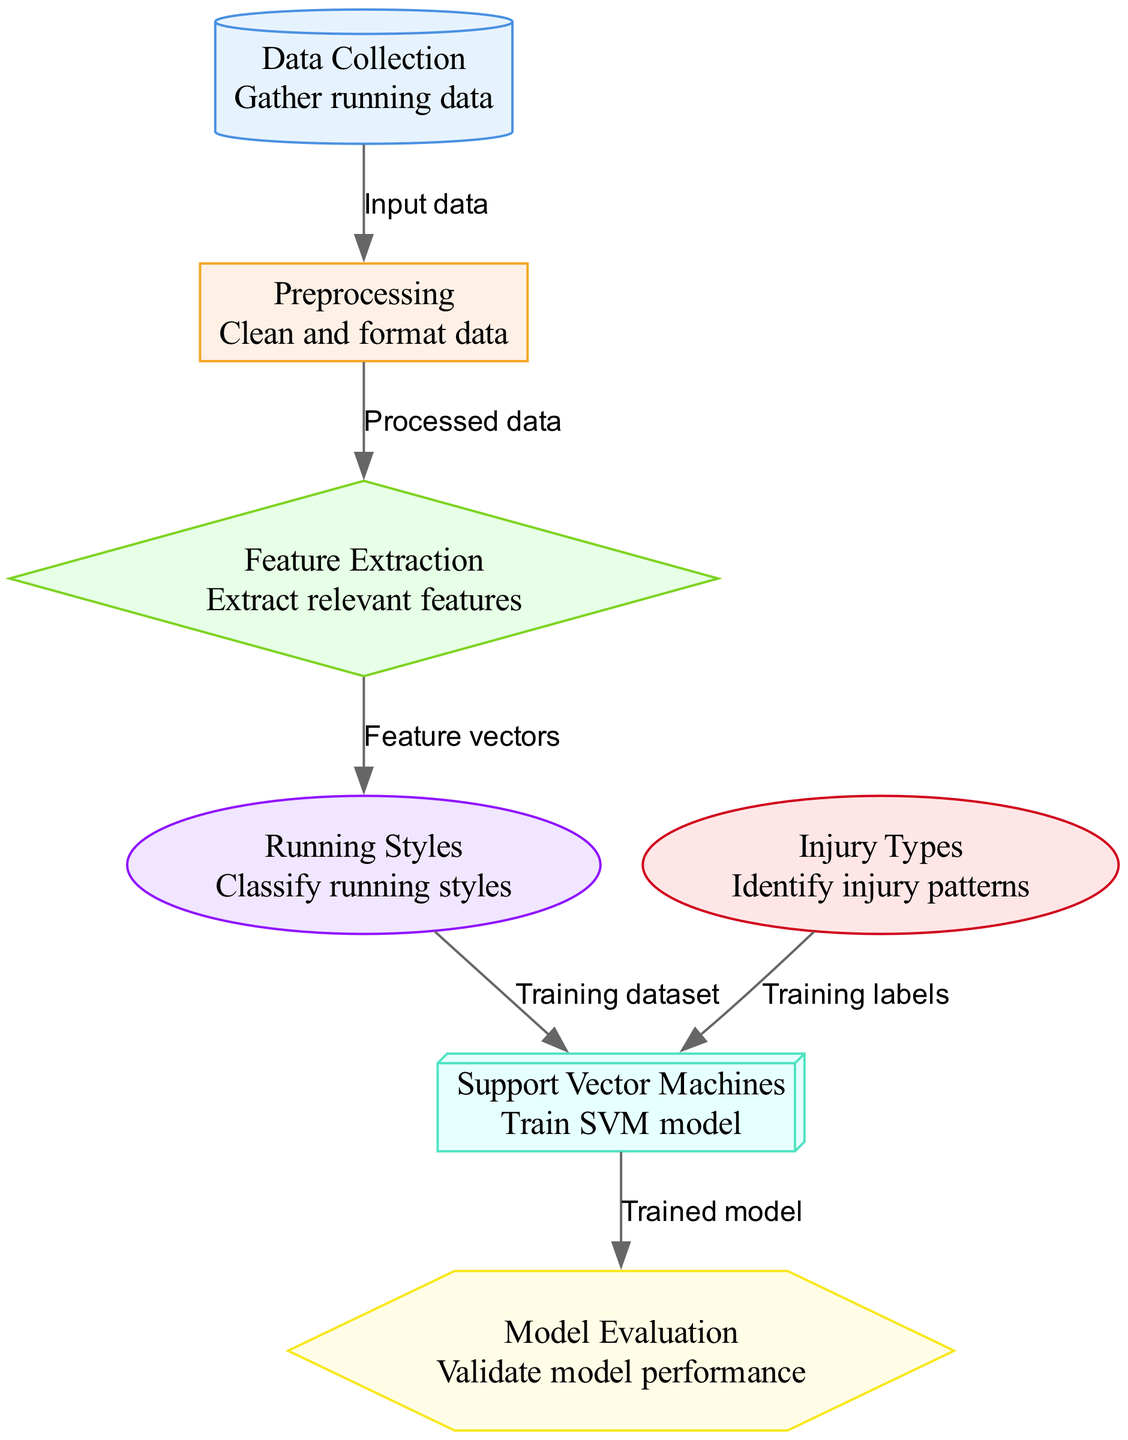What is the first node in the diagram? The first node shown in the diagram is labeled "Data Collection," which indicates it is the initial step in the process.
Answer: Data Collection How many nodes are present in the diagram? By counting each unique node listed in the diagram, we find there are seven nodes total.
Answer: 7 What is the purpose of the "Support Vector Machines" node? The "Support Vector Machines" node represents the training of the SVM model, which is crucial for classifying running styles and associating them with injury types.
Answer: Train SVM model What type of edge connects "Preprocessing" to "Feature Extraction"? The edge connecting "Preprocessing" to "Feature Extraction" is labeled "Processed data," indicating that this transition is based on the output from the preprocessing step.
Answer: Processed data Which nodes are connected to the "Support Vector Machines" node? The nodes connected to "Support Vector Machines" are "Running Styles" (from the training dataset) and "Injury Types" (from the training labels), demonstrating that both are essential for training the SVM model.
Answer: Running Styles and Injury Types What is the relationship between "Feature Extraction" and "Running Styles"? The relationship shown is that "Feature Extraction" provides "Feature vectors" to "Running Styles," which means this step is crucial for deriving the necessary input for classifying different styles of running.
Answer: Feature vectors Which node describes the task of classifying running styles? The node labeled "Running Styles" describes the task of classifying various ways in which individuals run, linking back to injury prevention.
Answer: Classify running styles What is the last step in the diagram? The last step in the diagram is "Model Evaluation," which involves validating the performance of the trained SVM model to ensure it predicts accurately.
Answer: Model Evaluation 